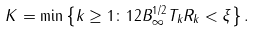<formula> <loc_0><loc_0><loc_500><loc_500>K = \min \left \{ k \geq 1 \colon 1 2 B _ { \infty } ^ { 1 / 2 } T _ { k } R _ { k } < \xi \right \} .</formula> 